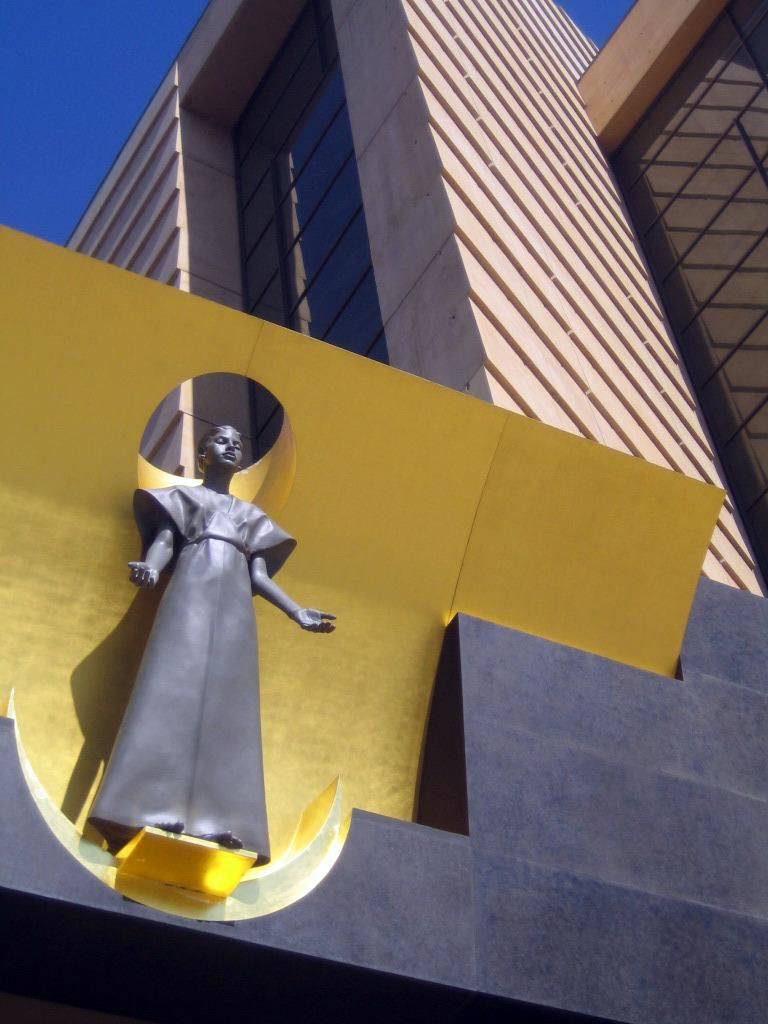What is the main subject of the image? There is a black color sculpture of a woman in the image. What can be seen in the background of the image? There is a building and a yellow color thing in the background of the image. What is visible above the building and the yellow thing? The sky is visible in the background of the image. What type of shock can be seen affecting the sculpture in the image? There is no shock present in the image; it features a sculpture of a woman. What country is the sculpture from in the image? The image does not provide information about the origin or country of the sculpture. 